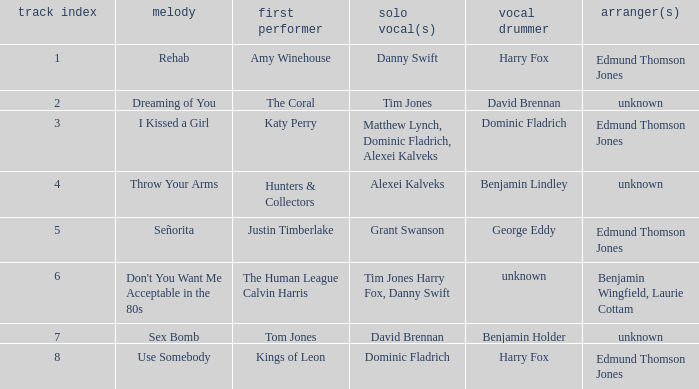Who is the vocal percussionist for Sex Bomb? Benjamin Holder. Parse the full table. {'header': ['track index', 'melody', 'first performer', 'solo vocal(s)', 'vocal drummer', 'arranger(s)'], 'rows': [['1', 'Rehab', 'Amy Winehouse', 'Danny Swift', 'Harry Fox', 'Edmund Thomson Jones'], ['2', 'Dreaming of You', 'The Coral', 'Tim Jones', 'David Brennan', 'unknown'], ['3', 'I Kissed a Girl', 'Katy Perry', 'Matthew Lynch, Dominic Fladrich, Alexei Kalveks', 'Dominic Fladrich', 'Edmund Thomson Jones'], ['4', 'Throw Your Arms', 'Hunters & Collectors', 'Alexei Kalveks', 'Benjamin Lindley', 'unknown'], ['5', 'Señorita', 'Justin Timberlake', 'Grant Swanson', 'George Eddy', 'Edmund Thomson Jones'], ['6', "Don't You Want Me Acceptable in the 80s", 'The Human League Calvin Harris', 'Tim Jones Harry Fox, Danny Swift', 'unknown', 'Benjamin Wingfield, Laurie Cottam'], ['7', 'Sex Bomb', 'Tom Jones', 'David Brennan', 'Benjamin Holder', 'unknown'], ['8', 'Use Somebody', 'Kings of Leon', 'Dominic Fladrich', 'Harry Fox', 'Edmund Thomson Jones']]} 